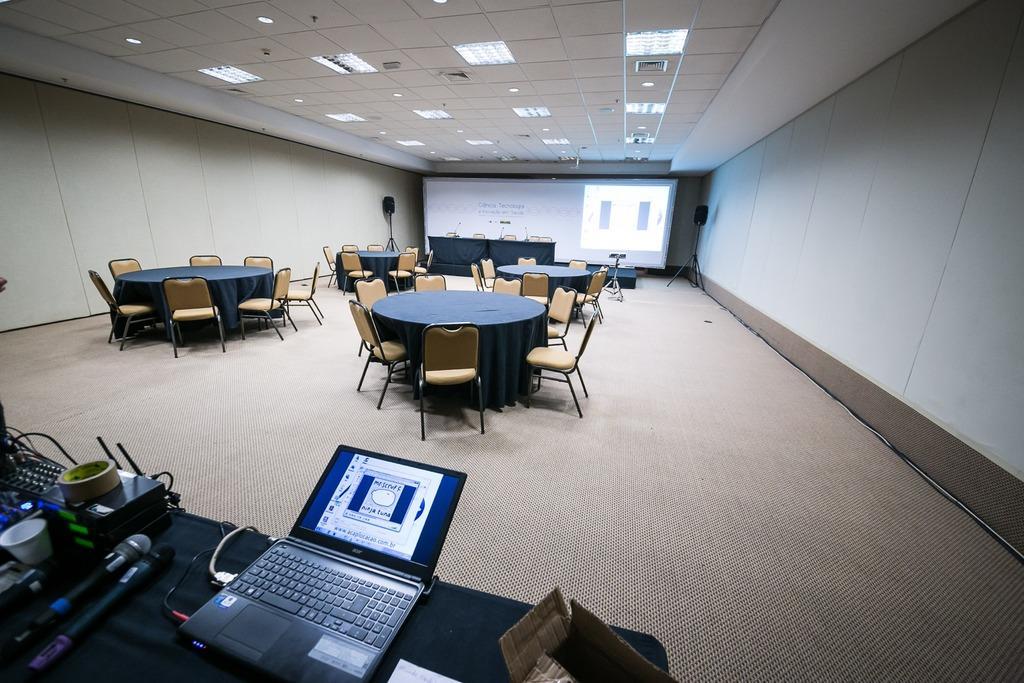Please provide a concise description of this image. This image is clicked inside a conference hall, there is table in the front with laptop,wifi router,mic and cup on it and in front there are many chairs around the tables and in the back there is a screen and above there are lights to the ceiling. 